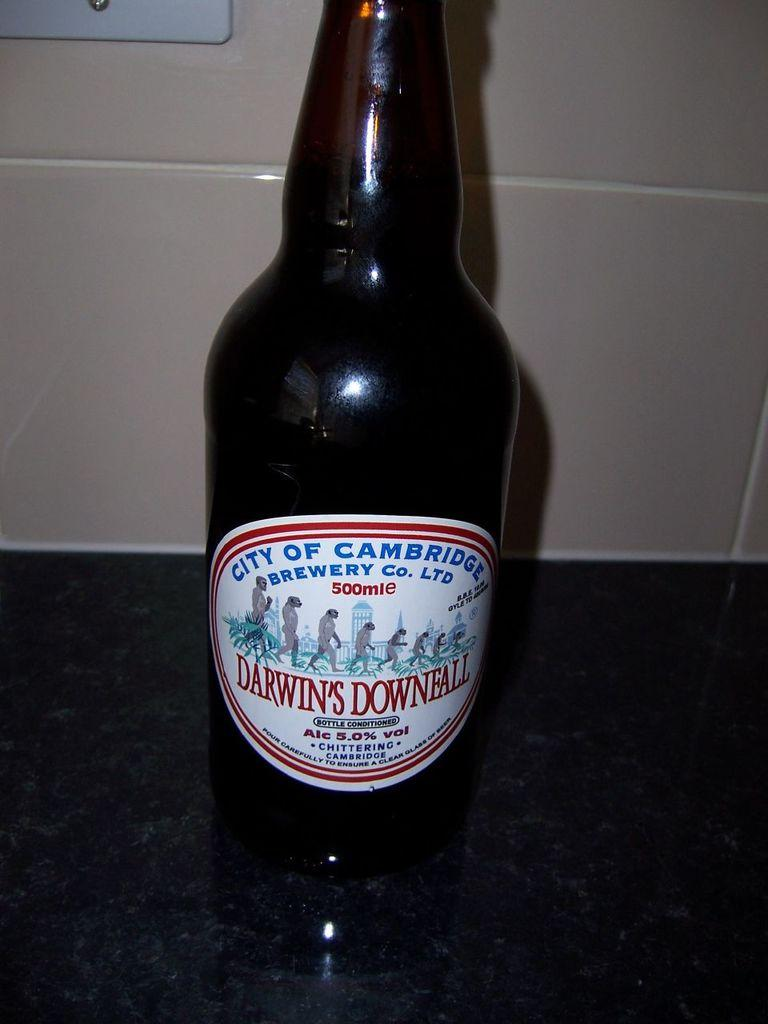<image>
Render a clear and concise summary of the photo. A bottle of Darwins Downfall sit on a counterl 